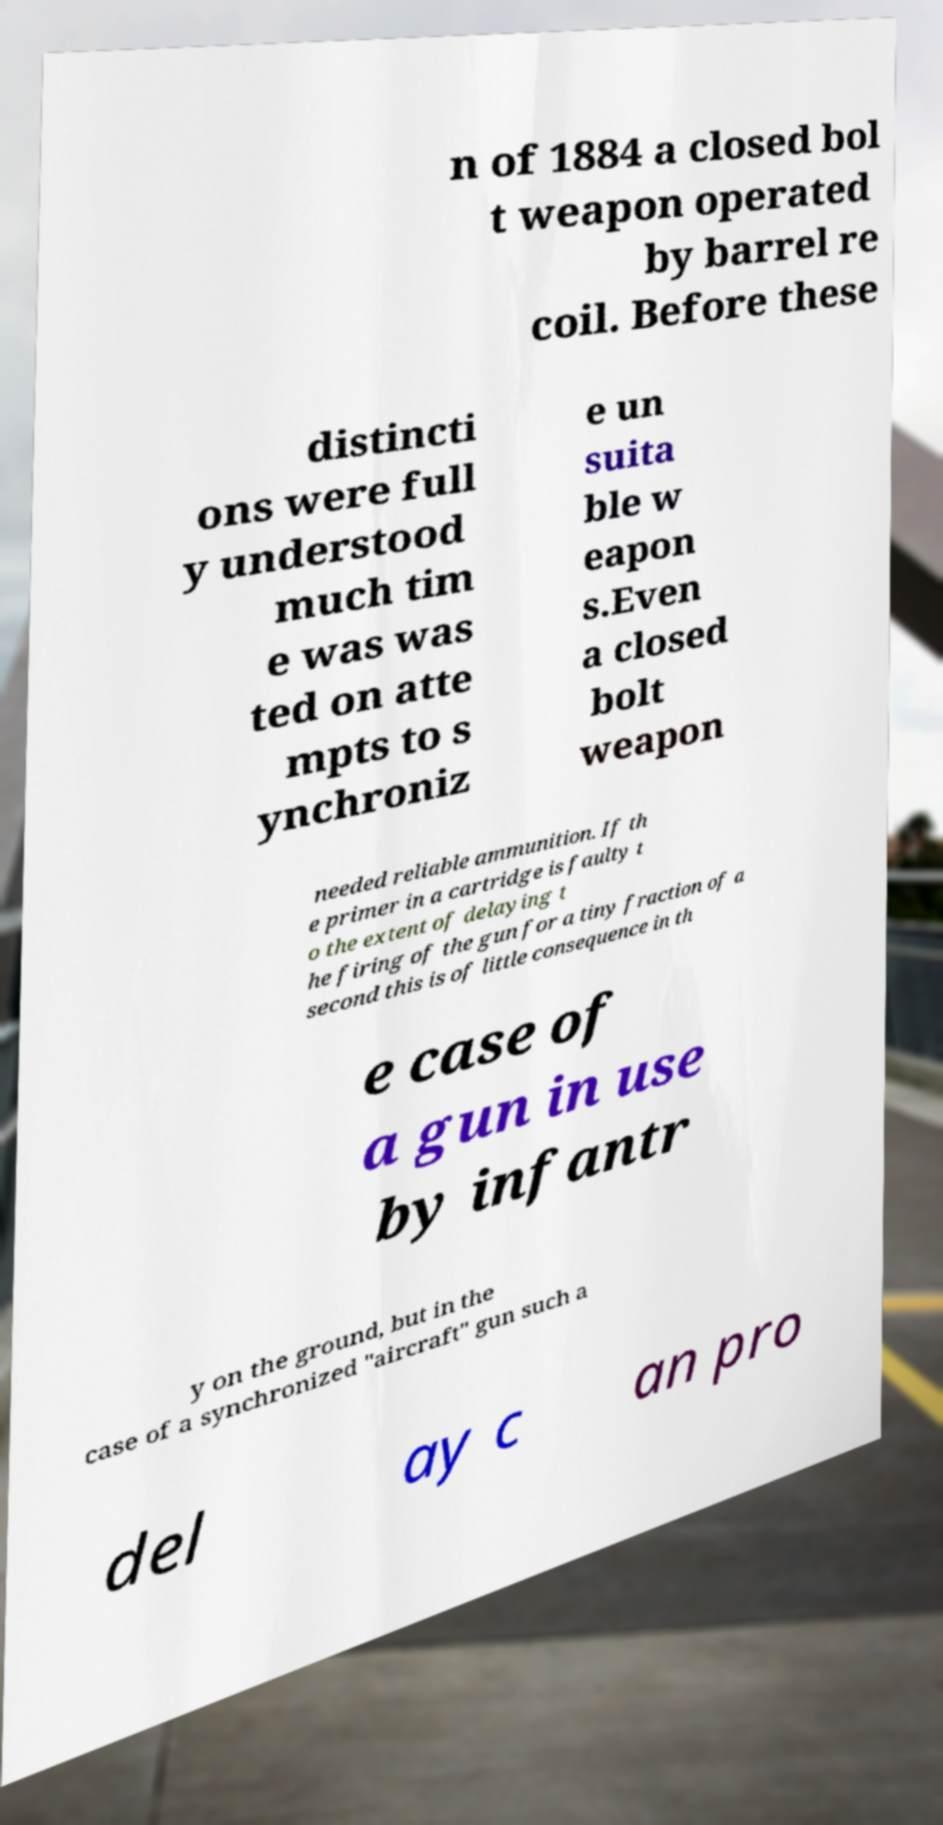Please identify and transcribe the text found in this image. n of 1884 a closed bol t weapon operated by barrel re coil. Before these distincti ons were full y understood much tim e was was ted on atte mpts to s ynchroniz e un suita ble w eapon s.Even a closed bolt weapon needed reliable ammunition. If th e primer in a cartridge is faulty t o the extent of delaying t he firing of the gun for a tiny fraction of a second this is of little consequence in th e case of a gun in use by infantr y on the ground, but in the case of a synchronized "aircraft" gun such a del ay c an pro 